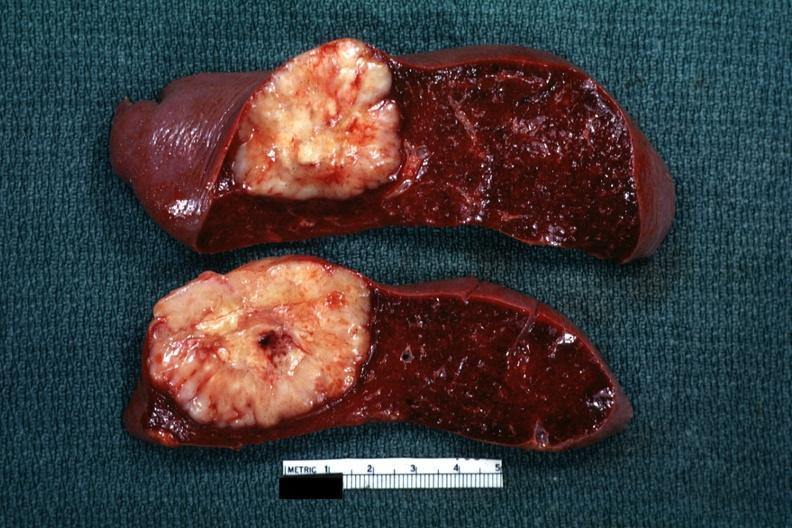how is single metastatic appearing lesion quite diagnosis was reticulum cell sarcoma?
Answer the question using a single word or phrase. Large 